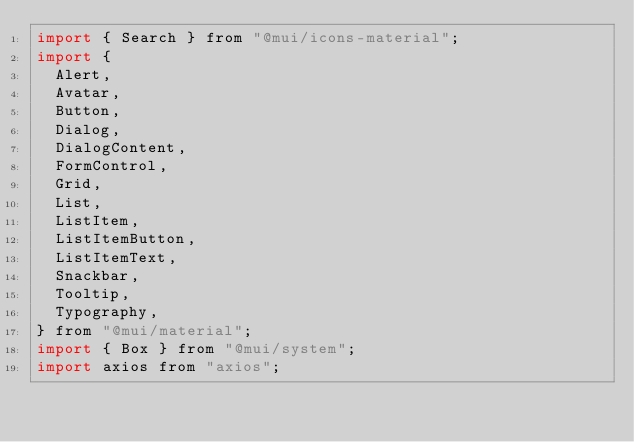Convert code to text. <code><loc_0><loc_0><loc_500><loc_500><_JavaScript_>import { Search } from "@mui/icons-material";
import {
  Alert,
  Avatar,
  Button,
  Dialog,
  DialogContent,
  FormControl,
  Grid,
  List,
  ListItem,
  ListItemButton,
  ListItemText,
  Snackbar,
  Tooltip,
  Typography,
} from "@mui/material";
import { Box } from "@mui/system";
import axios from "axios";</code> 